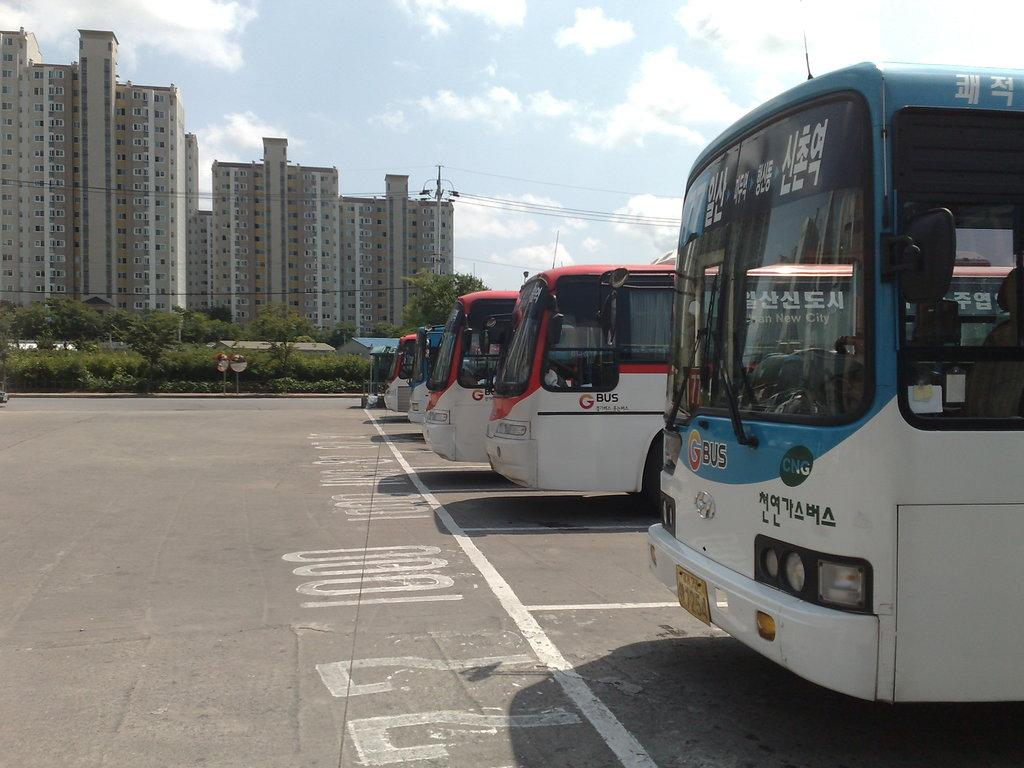<image>
Summarize the visual content of the image. A Blue G Bus sits in line with several other buses in a parking lot. 